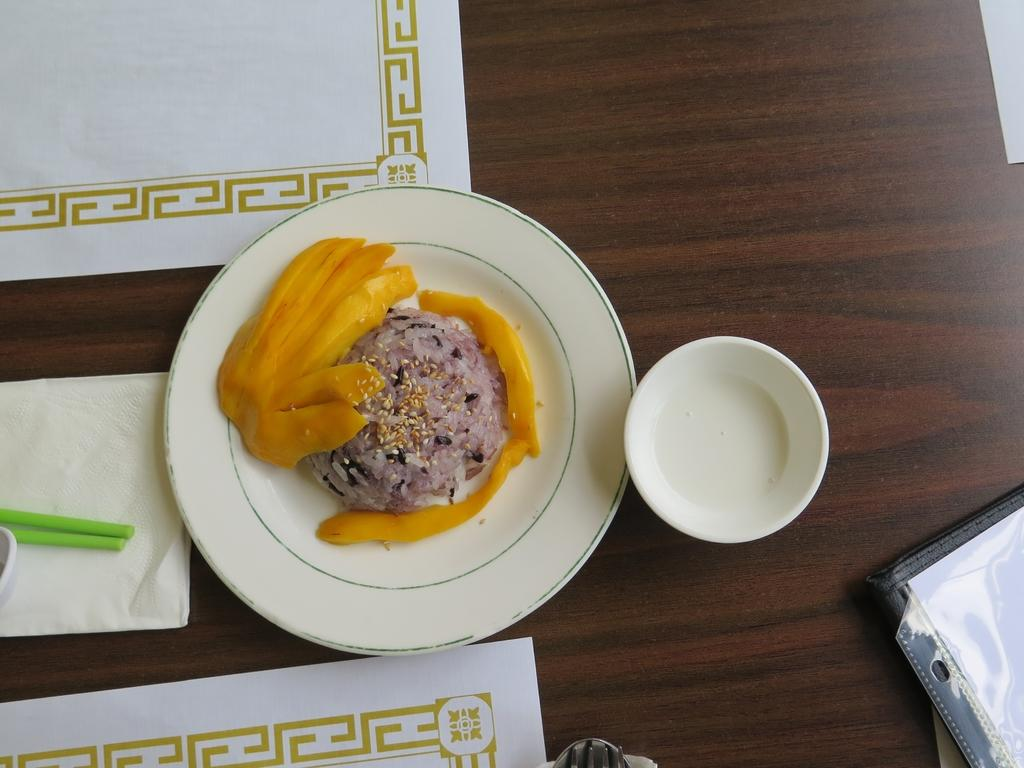What is the main food item visible on a plate in the image? There is a food item on a plate in the image, but the specific type of food cannot be determined from the provided facts. What other object can be seen on a table in the image? There is a bowl on a table in the image. What is placed inside the bowl on the table? There are objects on the bowl in the image, but the specific objects cannot be determined from the provided facts. How many dolls are sitting on the cast in the image? There is no cast or dolls present in the image. What type of drum is visible on the table in the image? There is no drum present in the image. 